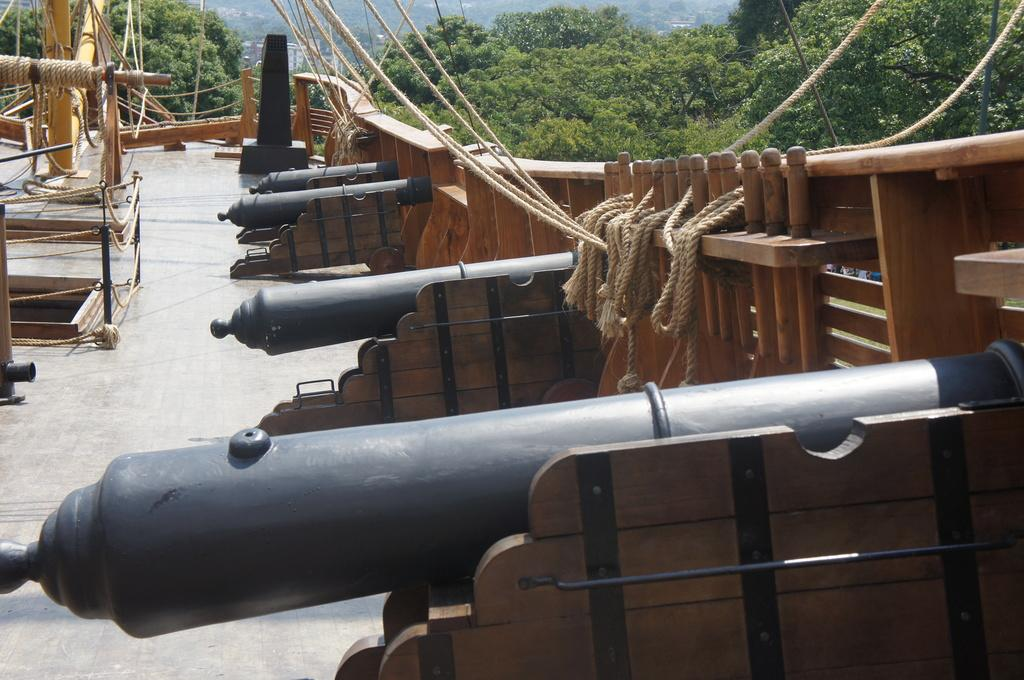What color are the cannons in the image? The cannons in the image are black. What can be seen on the right side of the image? There is a wooden railing on the right side of the image. What is attached to the railing? Some ropes are tied to the railing. What is visible in the background of the image? There are trees in the background of the image. What is the name of the carpenter's son in the image? There is no carpenter or son present in the image; it features cannons, a wooden railing, ropes, and trees. 